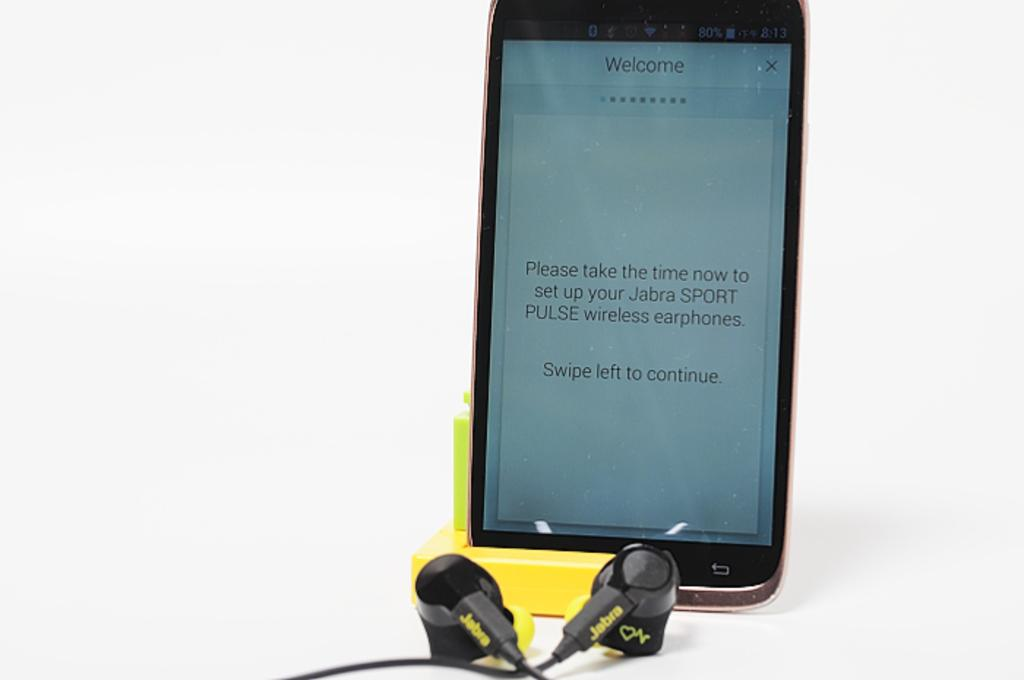What electronic device is visible in the image? There is a mobile phone in the image. What are the headsets used for? The headsets are used for listening to audio or communicating. On what surface are the objects placed? The objects are placed on a surface. What is the color of the background in the image? The background of the image is white in color. What type of authority figure can be seen in the image? There is no authority figure present in the image. Where is the lunchroom located in the image? There is no lunchroom present in the image. 